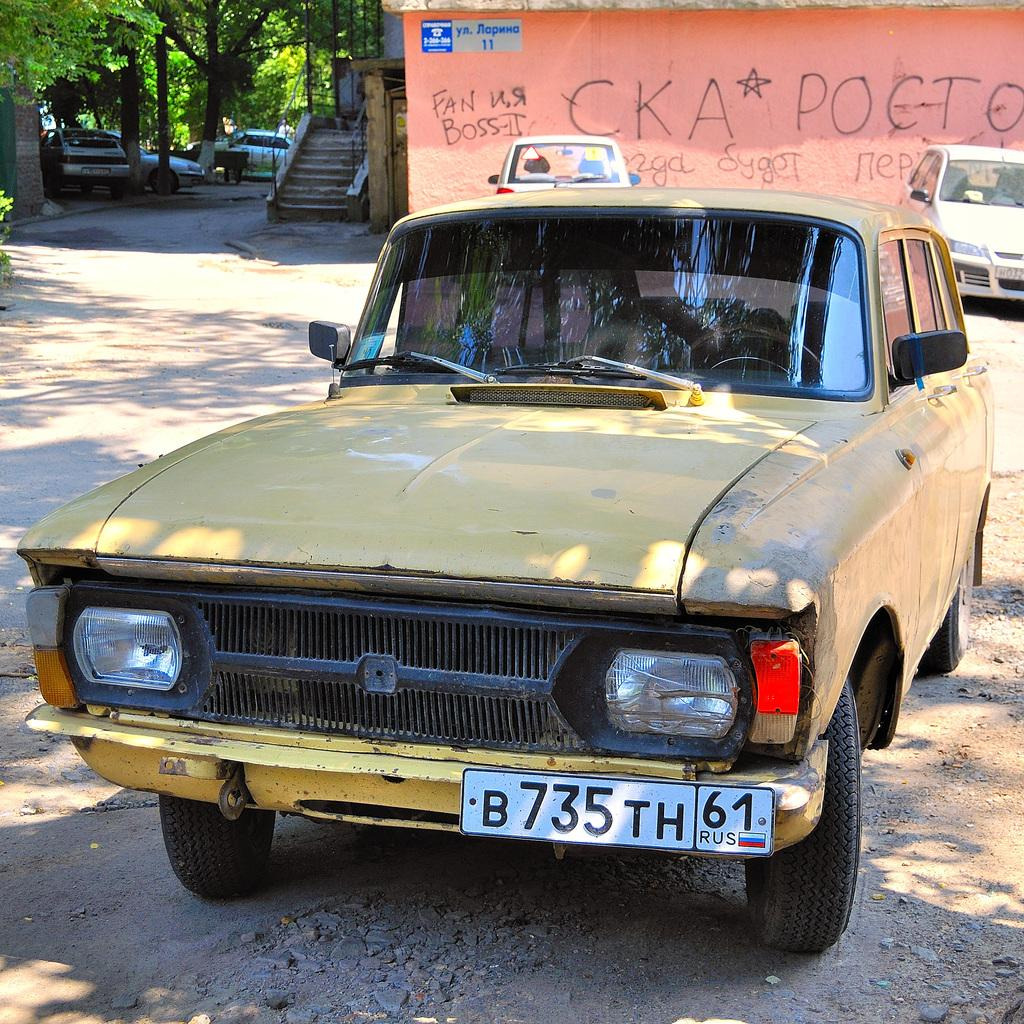<image>
Offer a succinct explanation of the picture presented. The old yellow car has a Russian tag B735TH. 